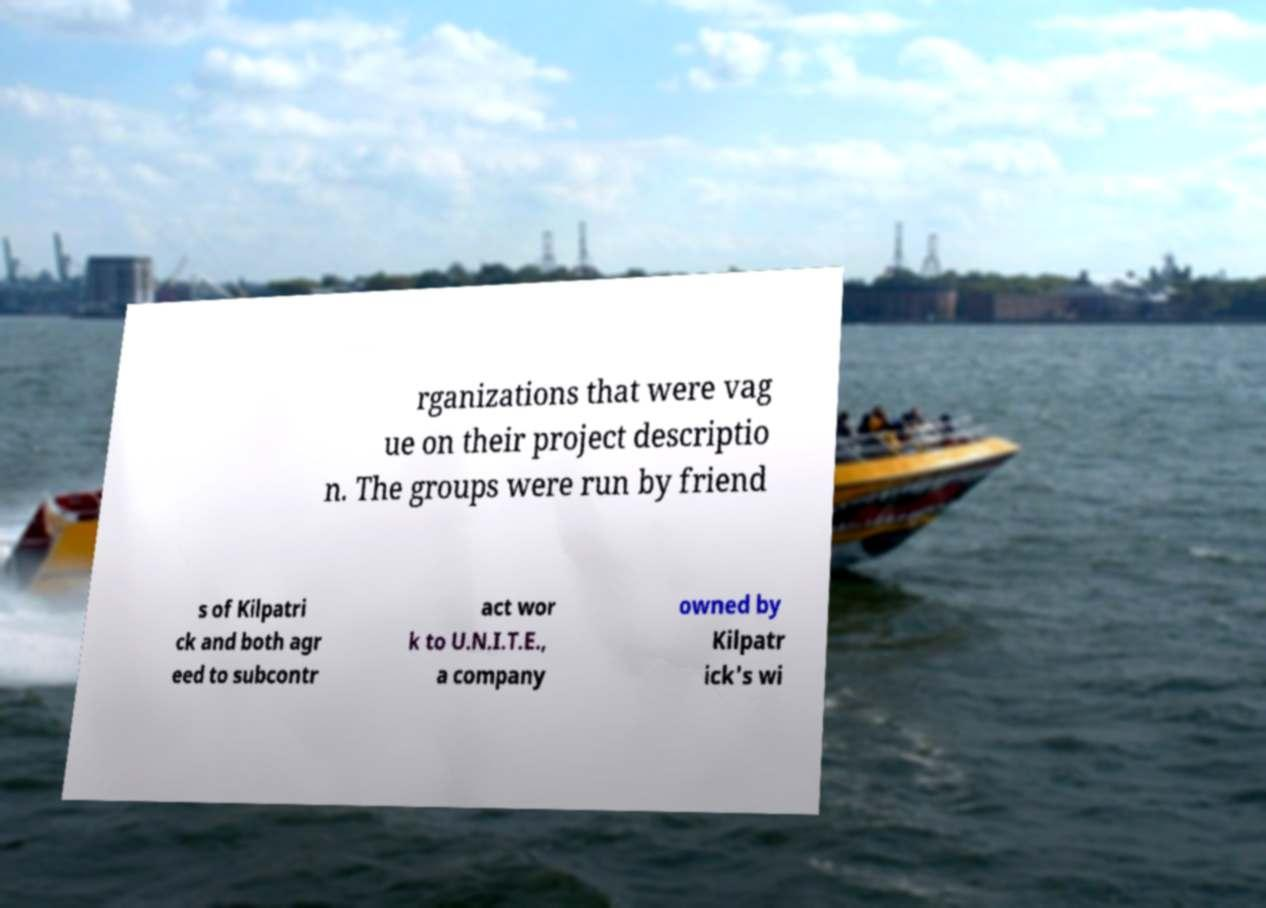Can you accurately transcribe the text from the provided image for me? rganizations that were vag ue on their project descriptio n. The groups were run by friend s of Kilpatri ck and both agr eed to subcontr act wor k to U.N.I.T.E., a company owned by Kilpatr ick's wi 